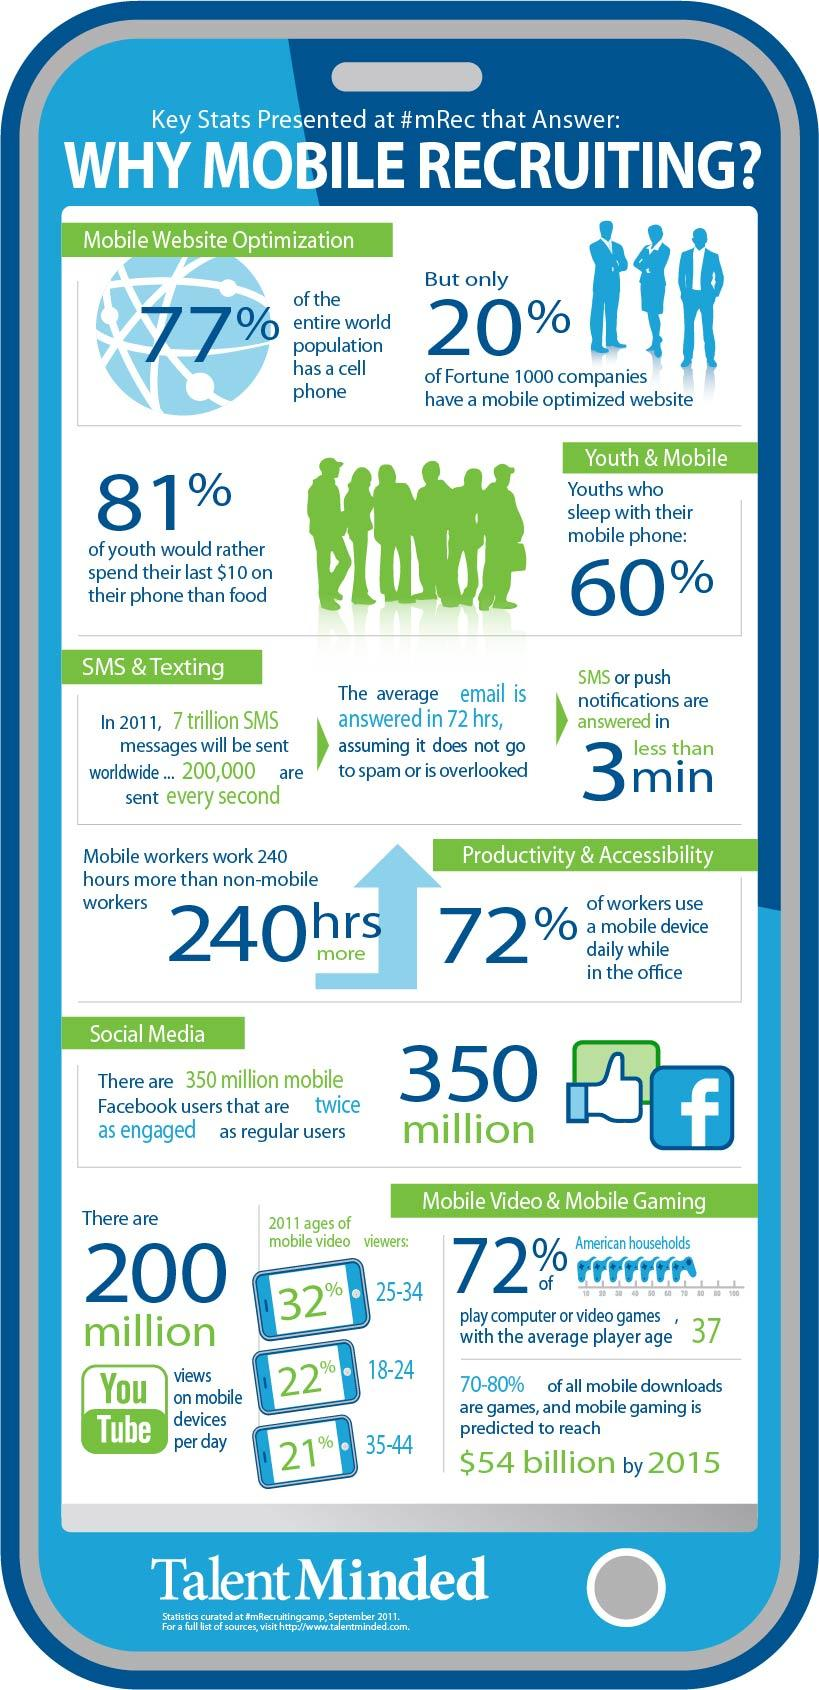Indicate a few pertinent items in this graphic. In 2011, 22% of mobile video viewers were in the age group of 18-24. In 2011, it was reported that 40% of youths did not sleep with their mobile phones. In 2011, 32% of mobile video viewers were in the age group of 25-34. In 2011, approximately 23% of the world's population did not have access to a mobile phone. In 2011, 28% of workers did not use mobile devices while in the office. 